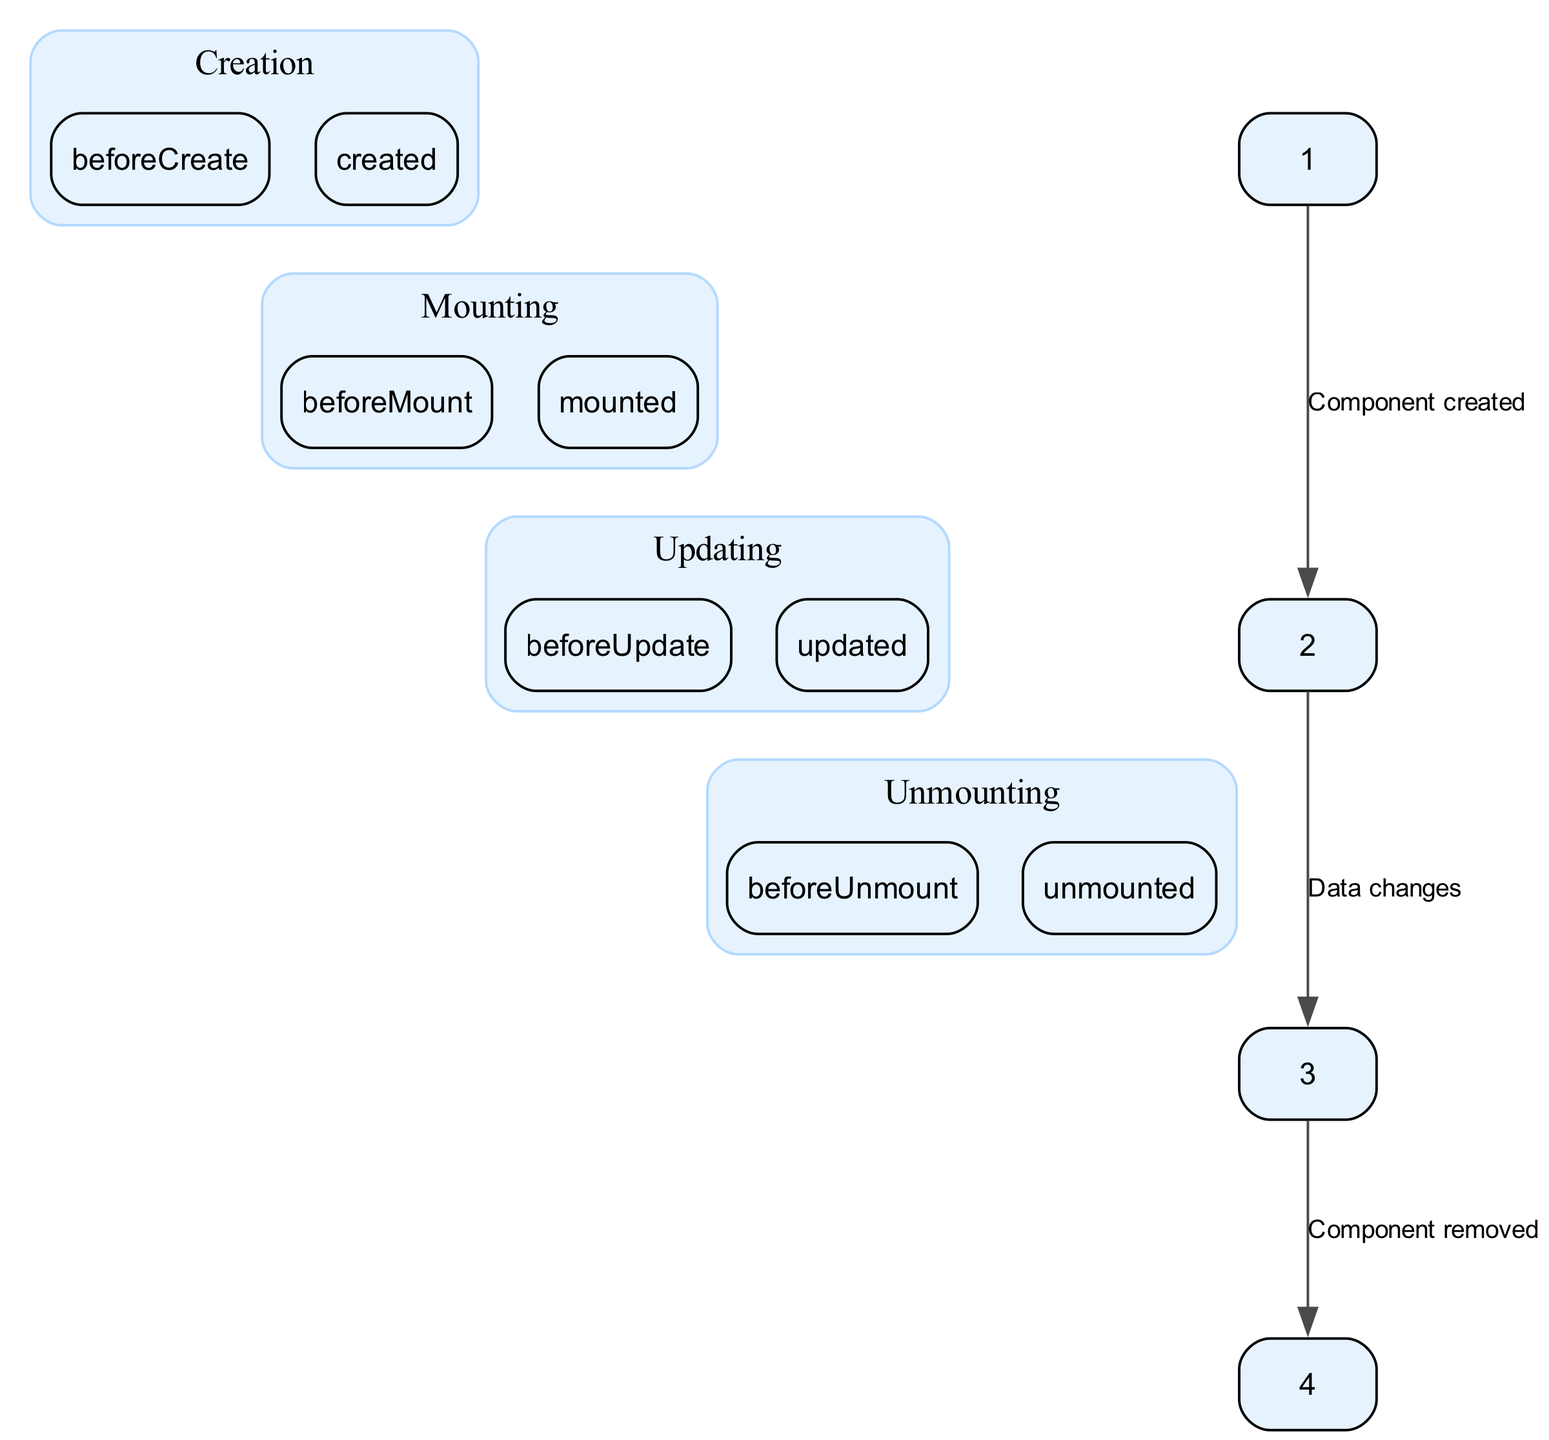What is the first lifecycle hook called during the creation phase? In the diagram, the creation phase has two children: "beforeCreate" and "created." The first listed child, which indicates the order of execution, is "beforeCreate."
Answer: beforeCreate How many hooks are there in the mounting phase? The mounting phase contains two children: "beforeMount" and "mounted." Therefore, there are two hooks in this phase.
Answer: 2 What follows the "created" hook in the lifecycle? According to the diagram, after the "created" hook (which is the last in the creation phase), the next phase is mounting, starting with the "beforeMount" hook.
Answer: beforeMount How many edges are displayed in the diagram? The diagram represents three edges connecting the four main lifecycle phases. These edges illustrate the transitions between creation, mounting, updating, and unmounting.
Answer: 3 What is the label for the edge connecting the updating phase to the unmounting phase? In the diagram, the edge connecting the updating phase to the unmounting phase is labeled "Component removed." This indicates the action that triggers the transition.
Answer: Component removed During what phase does the component stop updating? The updating phase comprises "beforeUpdate" and "updated." As indicated by the structure, the component transitions to the unmounting phase after finishing the updates.
Answer: Updating What lifecycle phase occurs after data changes? The diagram shows that after data changes, which connects the mounting phase to the updating phase, the next phase is updating.
Answer: Updating Which hook runs right before the component is destroyed? The last hook before the unmounting phase begins is "beforeUnmount." This hook signifies the final step in the lifecycle prior to the component being removed.
Answer: beforeUnmount 